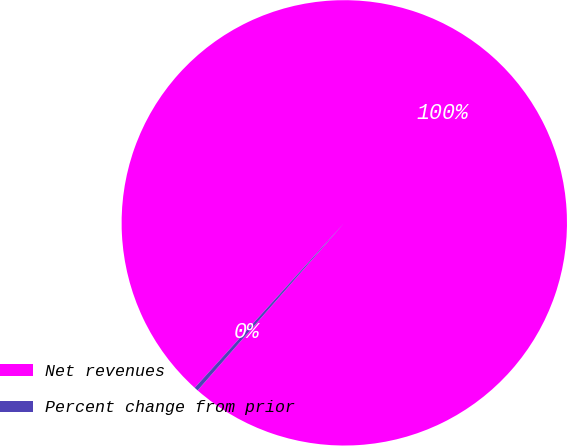Convert chart to OTSL. <chart><loc_0><loc_0><loc_500><loc_500><pie_chart><fcel>Net revenues<fcel>Percent change from prior<nl><fcel>99.72%<fcel>0.28%<nl></chart> 